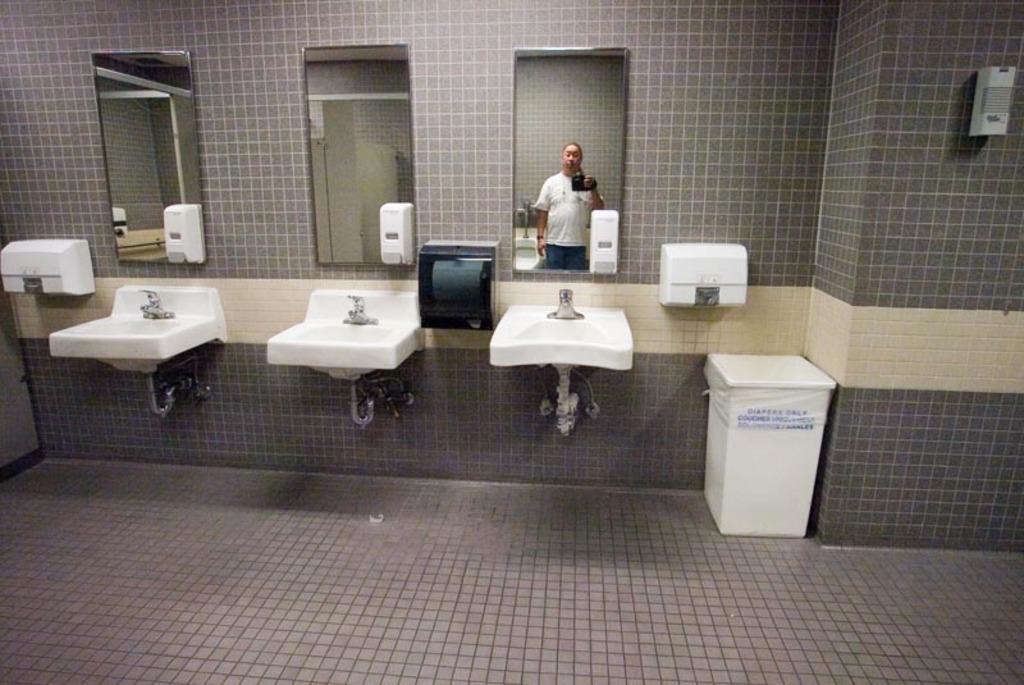In one or two sentences, can you explain what this image depicts? In this picture we can see mirrors placed on the wall, hand dryers, hand wash containers, wash basin with tap. We can see the reflection of a man. On the floor we can see a white trash bin. 